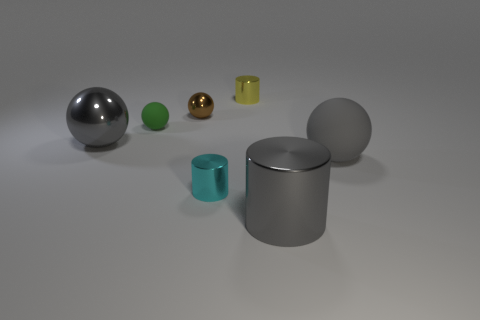Subtract all small rubber spheres. How many spheres are left? 3 Subtract all blue balls. Subtract all blue cubes. How many balls are left? 4 Add 1 large cylinders. How many objects exist? 8 Subtract all balls. How many objects are left? 3 Add 1 large matte spheres. How many large matte spheres are left? 2 Add 3 tiny red cylinders. How many tiny red cylinders exist? 3 Subtract 0 blue cylinders. How many objects are left? 7 Subtract all tiny brown things. Subtract all big gray spheres. How many objects are left? 4 